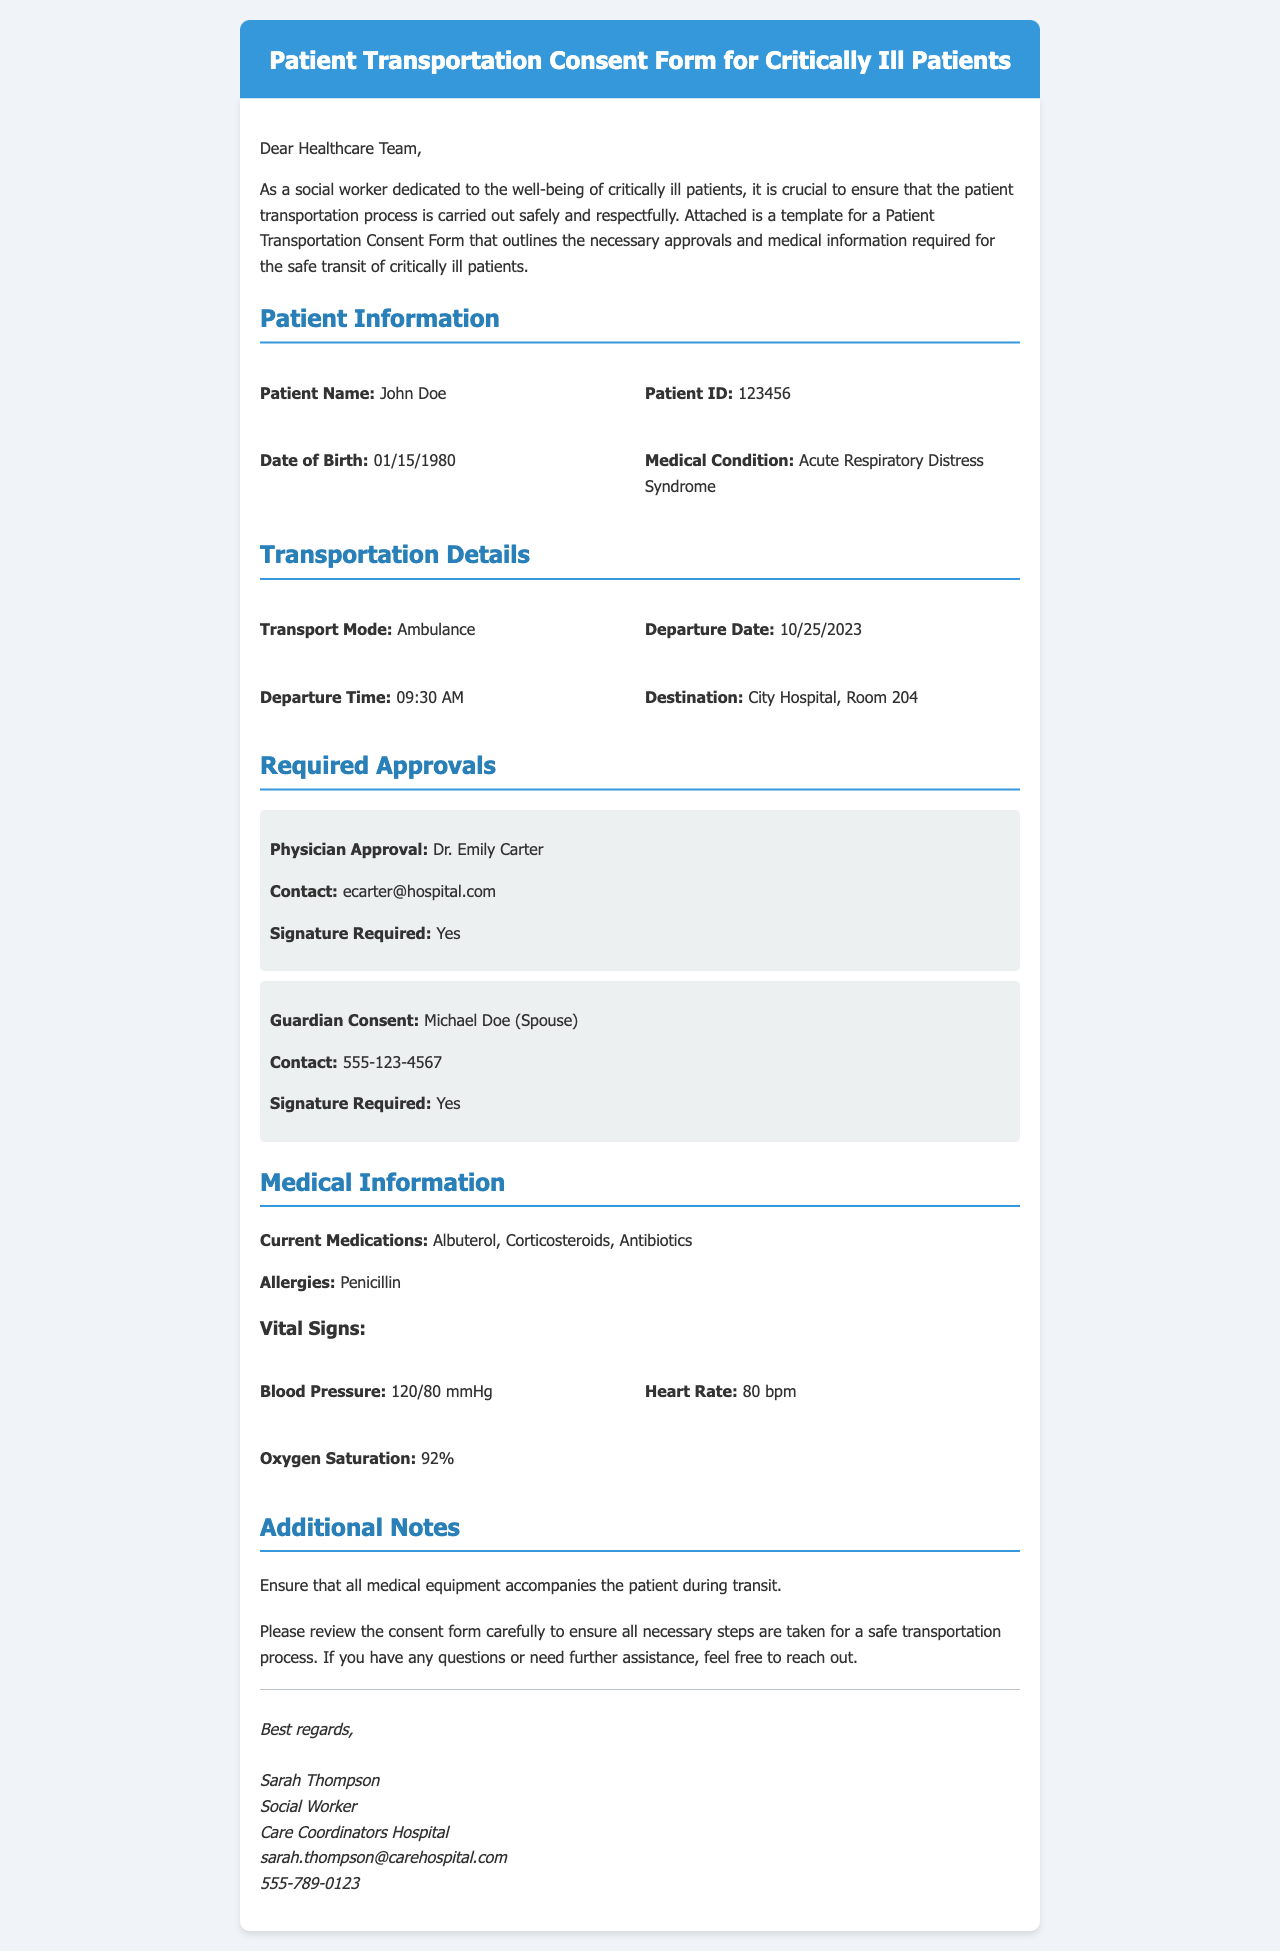What is the patient's name? The patient's name is clearly indicated in the document under "Patient Information."
Answer: John Doe What is the date of birth of the patient? The date of birth is specified in the "Patient Information" section of the document.
Answer: 01/15/1980 What is the medical condition of the patient? The medical condition is explicitly stated in the document under "Patient Information."
Answer: Acute Respiratory Distress Syndrome Who is the physician responsible for the patient? The physician's name is listed in the "Required Approvals" section.
Answer: Dr. Emily Carter What is the contact email for the physician? The physician's contact email can be found in the "Required Approvals" section.
Answer: ecarter@hospital.com What is the departure date for the transportation? The departure date is mentioned in the "Transportation Details" section.
Answer: 10/25/2023 What equipment is mentioned to ensure safe transit? The additional notes specify the type of equipment that must accompany the patient.
Answer: Medical equipment How many vital signs are listed in the document? The document lists blood pressure, heart rate, and oxygen saturation as vital signs, totaling three.
Answer: Three What does the guardian need to provide for approval? The document mentions that the guardian's approval is needed and that they must sign the form.
Answer: Signature What should be done if there are questions regarding the consent form? The document states that assistance is available if there are any questions.
Answer: Reach out for help 